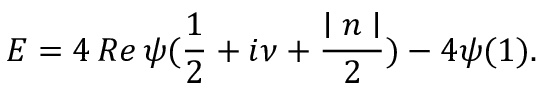Convert formula to latex. <formula><loc_0><loc_0><loc_500><loc_500>E = 4 \, R e \, \psi ( \frac { 1 } { 2 } + i \nu + \frac { | n | } 2 ) - 4 \psi ( 1 ) .</formula> 